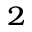<formula> <loc_0><loc_0><loc_500><loc_500>_ { 2 }</formula> 